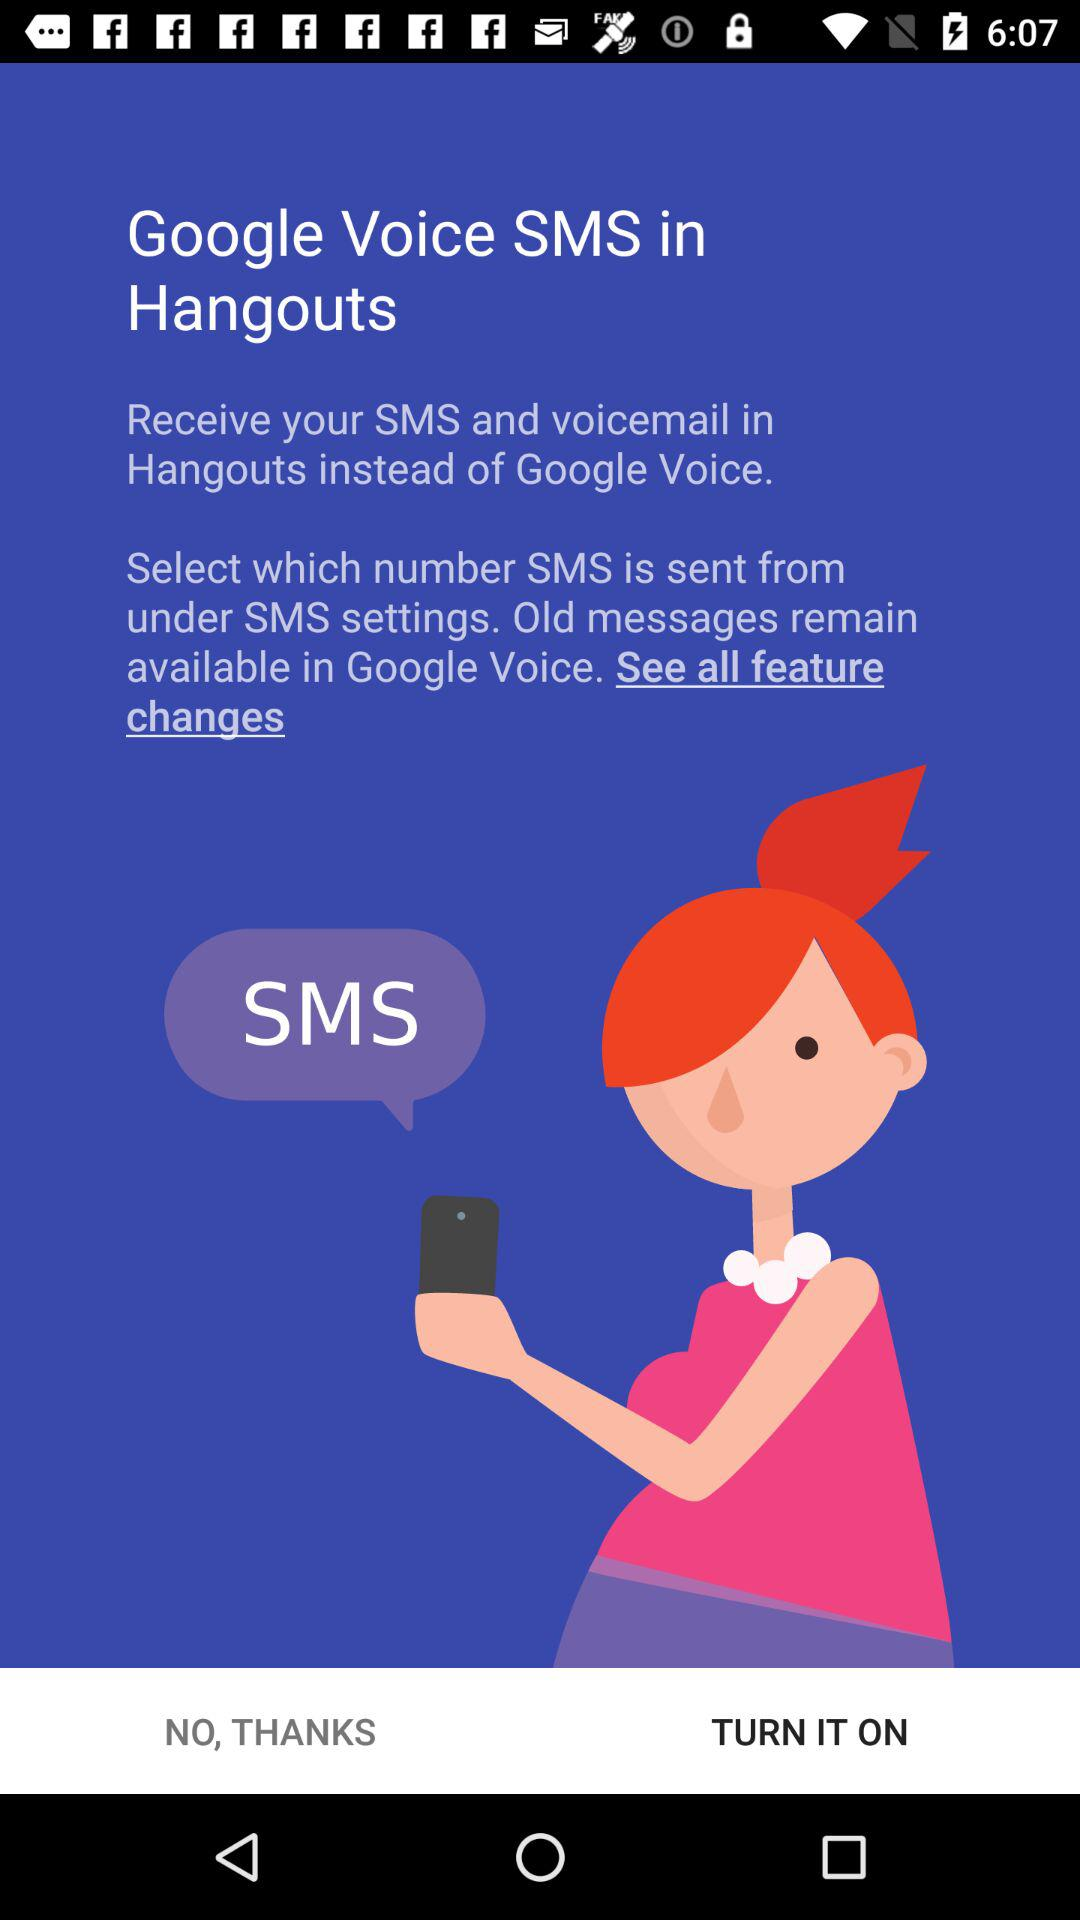What application can be used instead of "Google Voice" to receive SMS and voicemail? The application that can be used instead of "Google Voice" to receive SMS and voicemail is "Hangouts". 